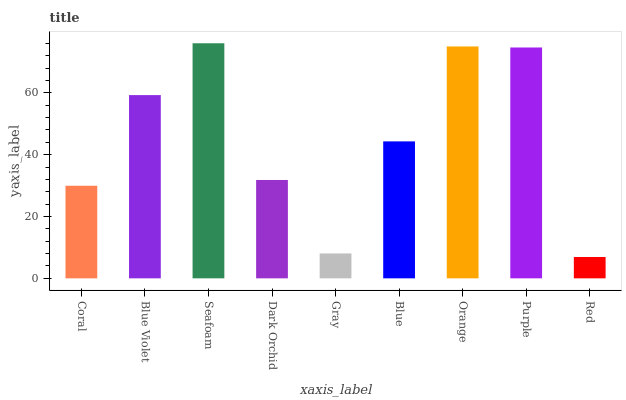Is Red the minimum?
Answer yes or no. Yes. Is Seafoam the maximum?
Answer yes or no. Yes. Is Blue Violet the minimum?
Answer yes or no. No. Is Blue Violet the maximum?
Answer yes or no. No. Is Blue Violet greater than Coral?
Answer yes or no. Yes. Is Coral less than Blue Violet?
Answer yes or no. Yes. Is Coral greater than Blue Violet?
Answer yes or no. No. Is Blue Violet less than Coral?
Answer yes or no. No. Is Blue the high median?
Answer yes or no. Yes. Is Blue the low median?
Answer yes or no. Yes. Is Gray the high median?
Answer yes or no. No. Is Orange the low median?
Answer yes or no. No. 